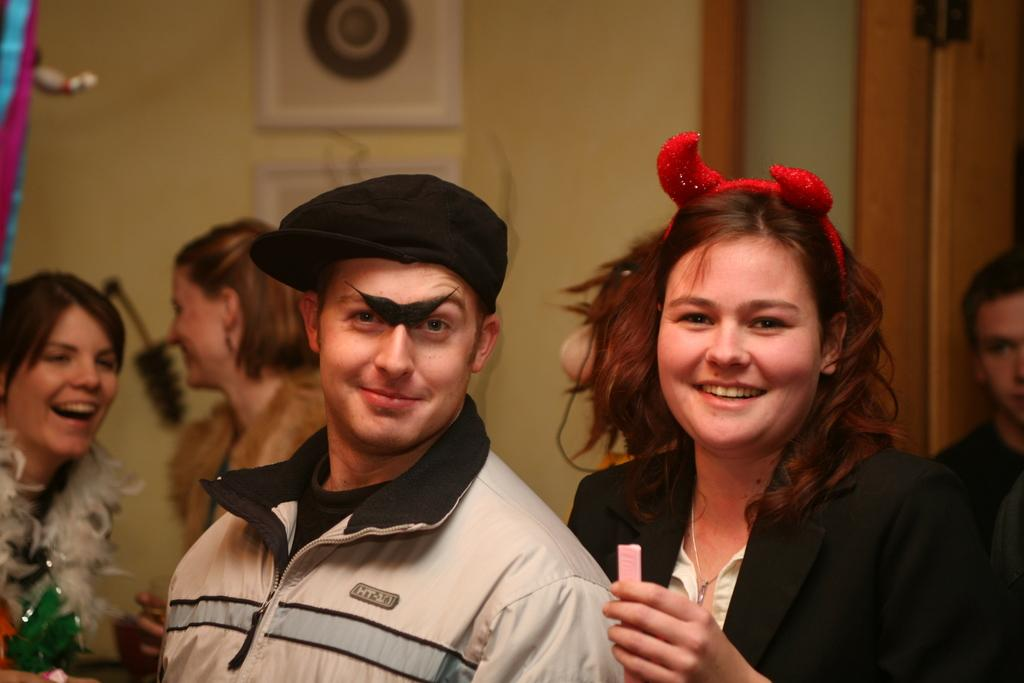What is happening in the image? There are people standing in the image. Can you describe the clothing of the people? The people are wearing different color dresses. What can be seen in the background of the image? There are objects visible in the background. What type of structure is present in the background? There is a wall in the background. Where is the hose located in the image? There is no hose present in the image. What type of sponge is being used by the people in the image? There is no sponge visible in the image. 